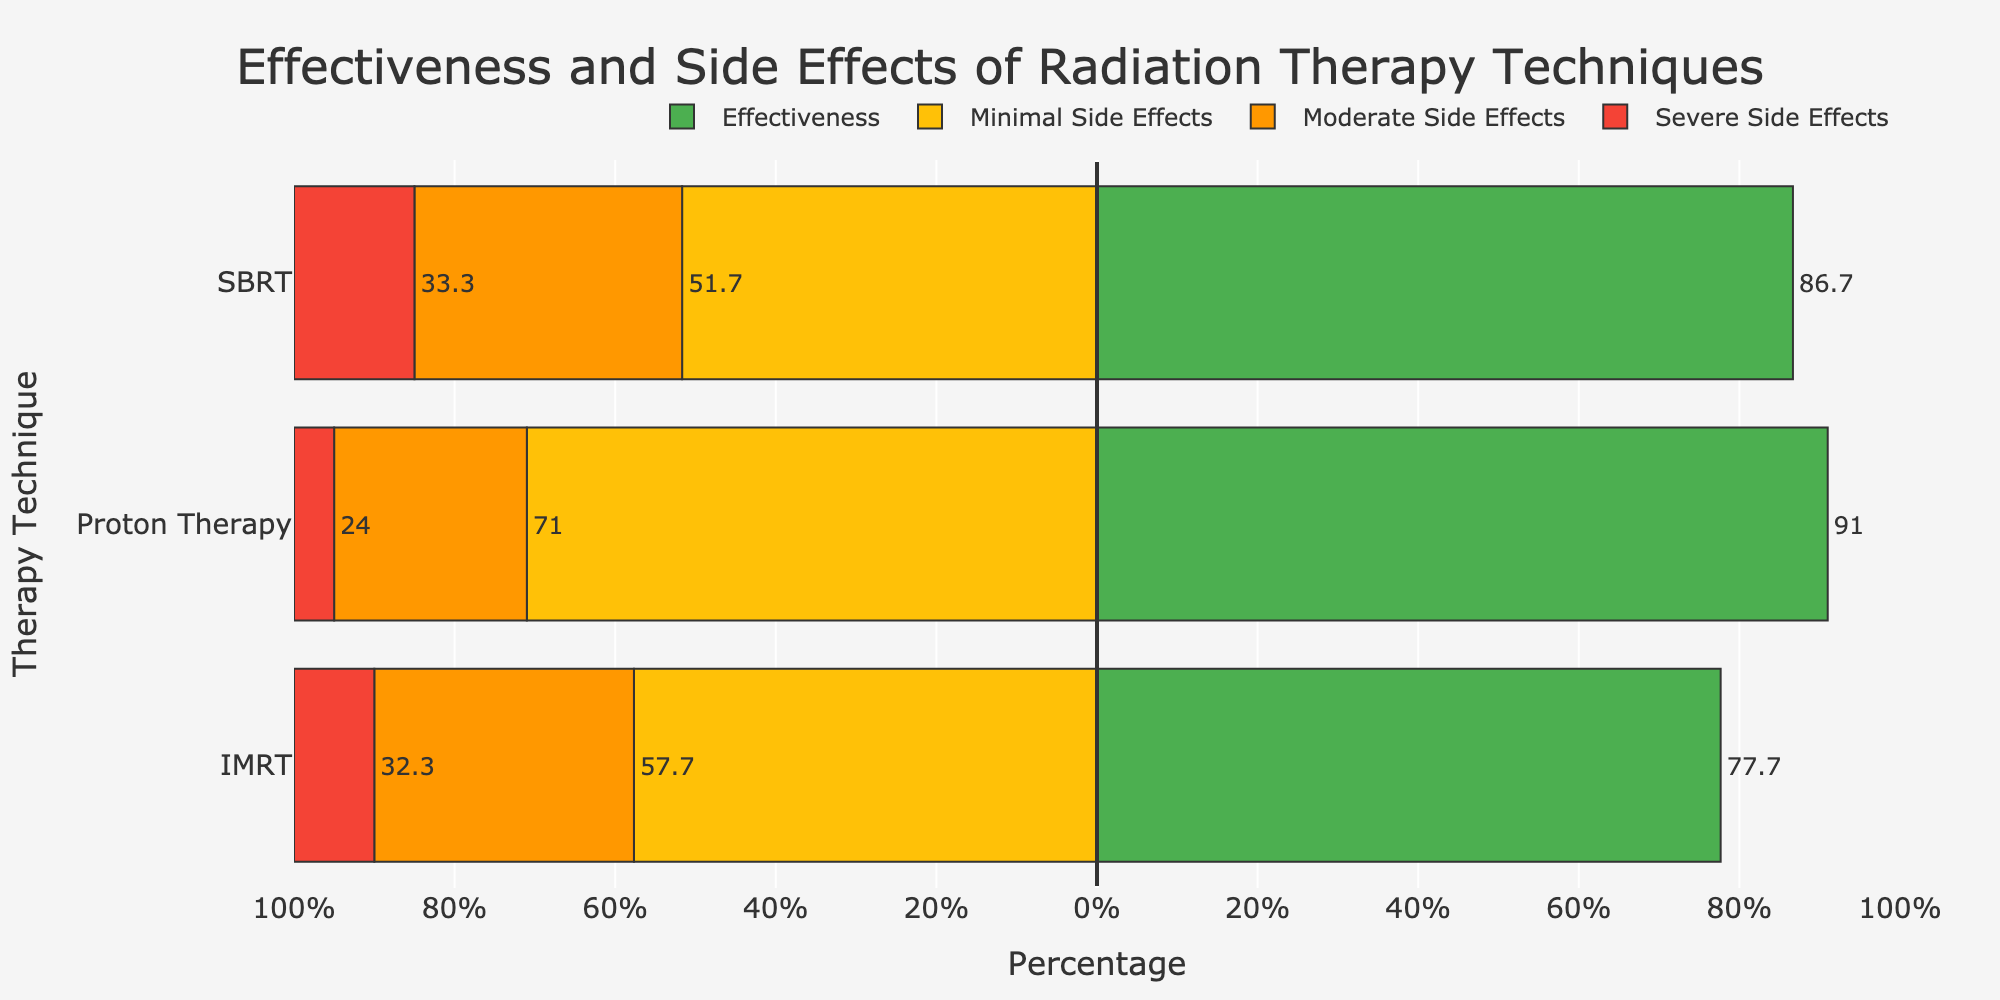What is the average effectiveness of all three radiation therapy techniques? The effectiveness of each therapy is provided in the figure as IMRT: 77.7, SBRT: 86.7, and Proton Therapy: 91. We sum these values and divide by three to get the overall average effectiveness: (77.7 + 86.7 + 91) / 3 ≈ 85.13
Answer: 85.133 Which therapy technique has the highest effectiveness? The figure shows the average effectiveness for each therapy. Proton Therapy has the highest value with around 91%.
Answer: Proton Therapy How do the minimal side effects for Proton Therapy compare with those for IMRT? By comparing the average values from the figure, we see that Proton Therapy has minimal side effects at around 71%, while IMRT has around 57.7%. Proton Therapy has higher minimal side effects than IMRT.
Answer: Proton Therapy is higher What is the difference in severe side effects between SBRT and Proton Therapy? From the figure, we find the average severe side effects for SBRT is 15% and for Proton Therapy is 5%. Subtracting these, the difference is 15% - 5% = 10%.
Answer: 10% What is the combined percentage of minimal and moderate side effects for IMRT? From the figure, IMRT has minimal side effects of around 57.7% and moderate side effects of 32.3%. Adding these, the combined percentage is 57.7% + 32.3% = 90%.
Answer: 90% How does the total of moderate and severe side effects compare across the three therapies? Summing the moderate and severe side effects from the figure: IMRT (32.3% + 10% = 42.3%), SBRT (33.3% + 15% = 48.3%), and Proton Therapy (24% + 5% = 29%). Proton Therapy has the lowest total, SBRT the highest, and IMRT is in between.
Answer: Proton Therapy: lowest, SBRT: highest Which therapy has the smallest proportion of severe side effects? The figure shows the average severe side effects for Proton Therapy at 5%, followed by IMRT and SBRT at 10% and 15%, respectively. Proton Therapy has the smallest proportion.
Answer: Proton Therapy What is the visual difference in bar length between the minimal side effects of SBRT and Proton Therapy? Visually, the minimal side effects bar for Proton Therapy extends further to the left than for SBRT. Proton Therapy has a higher value (71%) compared to SBRT (51.7%). So, Proton Therapy has a longer minimal side effects bar.
Answer: Proton Therapy's bar is longer If one therapy is chosen based only on minimizing moderate side effects, which should it be? The average moderate side effects are shown in the figure as IMRT: 32.3%, SBRT: 33.3%, and Proton Therapy: 24%. Proton Therapy has the lowest moderate side effects.
Answer: Proton Therapy 